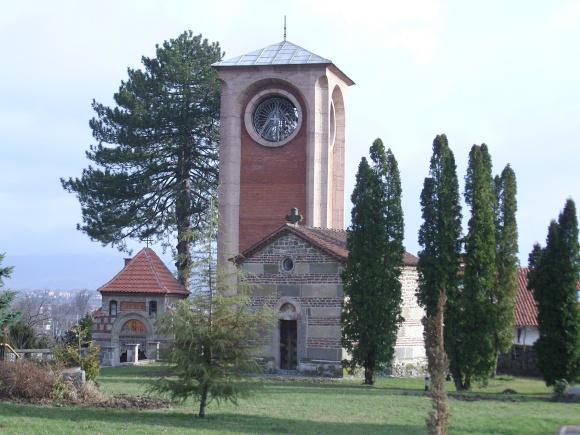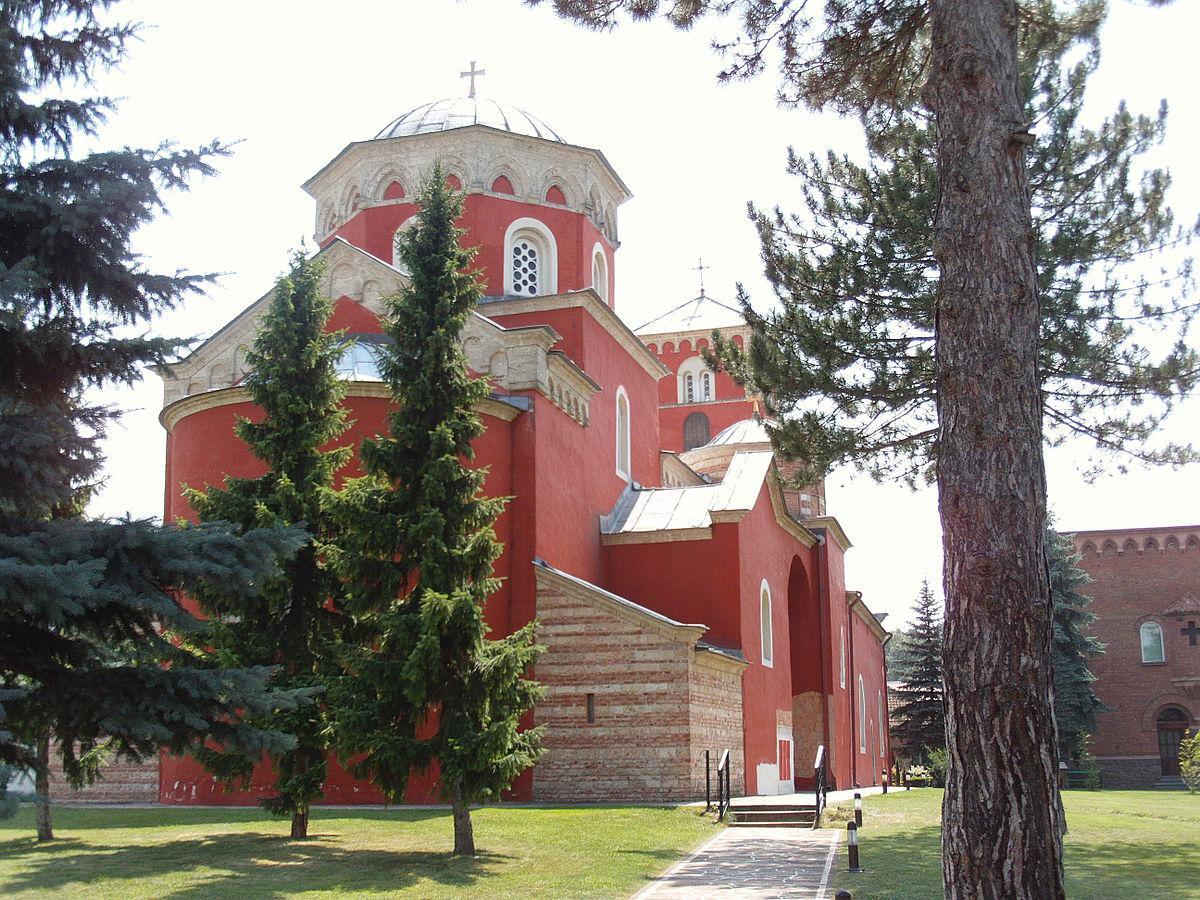The first image is the image on the left, the second image is the image on the right. Examine the images to the left and right. Is the description "Left image shows sprawling architecture with an orange domed semi-cylinder flanked by peak-roofed brown structures facing the camera." accurate? Answer yes or no. No. 